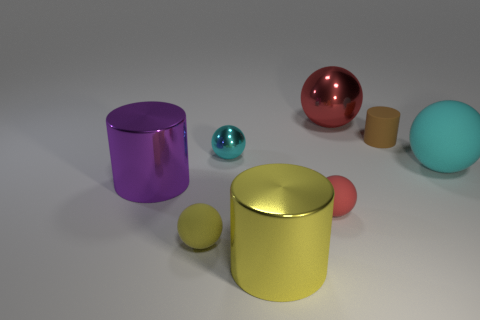Subtract 2 spheres. How many spheres are left? 3 Subtract all large metallic balls. How many balls are left? 4 Subtract all purple balls. Subtract all purple cylinders. How many balls are left? 5 Add 2 matte balls. How many objects exist? 10 Subtract all balls. How many objects are left? 3 Add 7 purple metallic things. How many purple metallic things are left? 8 Add 3 big yellow metallic blocks. How many big yellow metallic blocks exist? 3 Subtract 0 gray balls. How many objects are left? 8 Subtract all small yellow metal cylinders. Subtract all small cyan shiny balls. How many objects are left? 7 